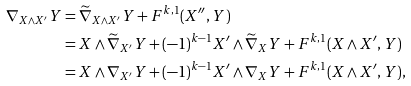<formula> <loc_0><loc_0><loc_500><loc_500>\nabla _ { X \wedge X ^ { \prime } } Y & = \widetilde { \nabla } _ { X \wedge X ^ { \prime } } Y + F ^ { k , 1 } ( X ^ { \prime \prime } , Y ) \\ & = X \wedge \widetilde { \nabla } _ { X ^ { \prime } } Y + ( - 1 ) ^ { k - 1 } X ^ { \prime } \wedge \widetilde { \nabla } _ { X } Y + F ^ { k , 1 } ( X \wedge X ^ { \prime } , Y ) \\ & = X \wedge \nabla _ { X ^ { \prime } } Y + ( - 1 ) ^ { k - 1 } X ^ { \prime } \wedge \nabla _ { X } Y + F ^ { k , 1 } ( X \wedge X ^ { \prime } , Y ) ,</formula> 